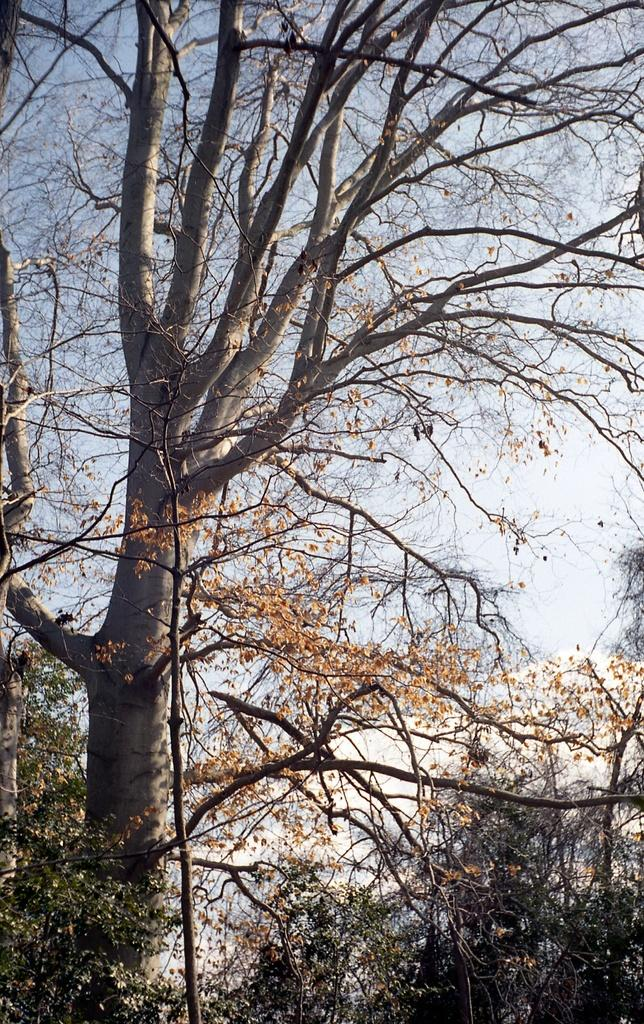What type of vegetation is in the foreground of the image? There are trees in the foreground of the image. What part of the natural environment is visible in the background of the image? The sky is visible in the background of the image. What type of fuel is being used by the beginner in the image? There is no person or fuel present in the image; it only features trees in the foreground and the sky in the background. 